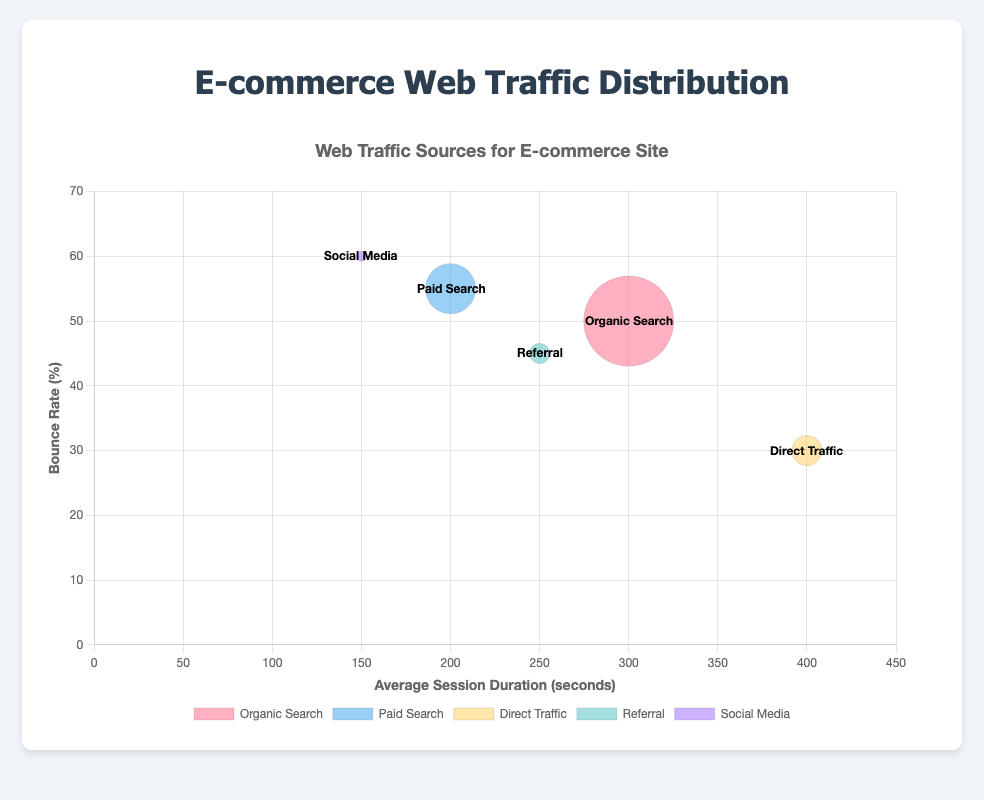What's the title of the chart? The chart's title is displayed at the top, which reads "Web Traffic Sources for E-commerce Site".
Answer: Web Traffic Sources for E-commerce Site Which traffic source has the highest average session duration? By looking at the x-axis, Direct Traffic has the highest position at 400 seconds, which is greater than the other sources.
Answer: Direct Traffic What is the bounce rate for Social Media? The y-axis shows that Social Media is positioned at 60%, indicating its bounce rate.
Answer: 60% Which traffic source contributes the least to web traffic? The size of the bubble represents the contribution percentage. Social Media has the smallest bubble with 5%.
Answer: Social Media Does Organic Search have a higher or lower bounce rate compared to Paid Search? Comparing the y-axis positions, Organic Search (50%) has a lower bounce rate than Paid Search (55%).
Answer: Lower How many different traffic sources are represented in the chart? There are five different bubbles in the chart, each representing a different traffic source.
Answer: 5 What's the total percentage of web traffic from Organic Search and Direct Traffic combined? Organic Search is 45% and Direct Traffic is 15%, thus 45% + 15% = 60%.
Answer: 60% Which source has a greater average session duration: Referral or Paid Search? On the x-axis, Referral is at 250 seconds, while Paid Search is at 200 seconds. Hence, Referral has a greater duration.
Answer: Referral Compare the bounce rates of Referral and Direct Traffic. Which one is lower? Referral is at 45% while Direct Traffic is at 30% on the y-axis. Thus, Direct Traffic has a lower bounce rate.
Answer: Direct Traffic What can you infer about the relationship between average session duration and bounce rate from this chart? Generally, sources with higher average session durations tend to have lower bounce rates. For instance, Direct Traffic with 400s (longest duration) shows a low bounce rate (30%), while Social Media with the shortest duration (150s) has the highest bounce rate (60%).
Answer: Higher session duration usually means lower bounce rate 